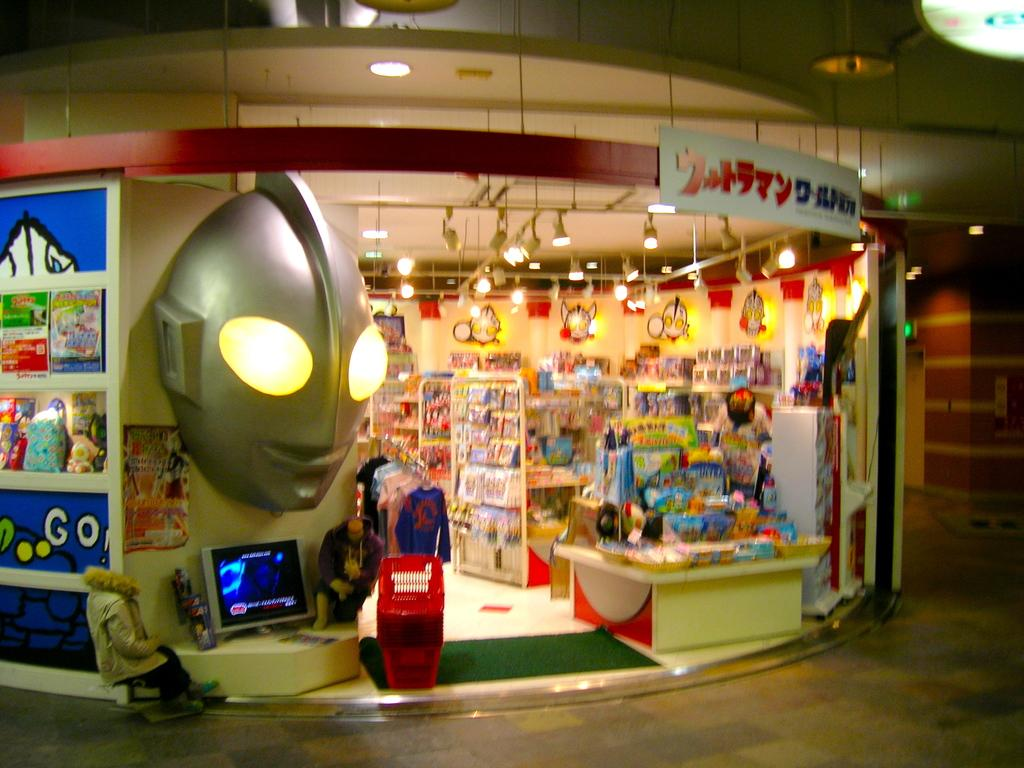<image>
Share a concise interpretation of the image provided. Meet us near the GO words to the left of the gold alien head statute right outside the toy store. 